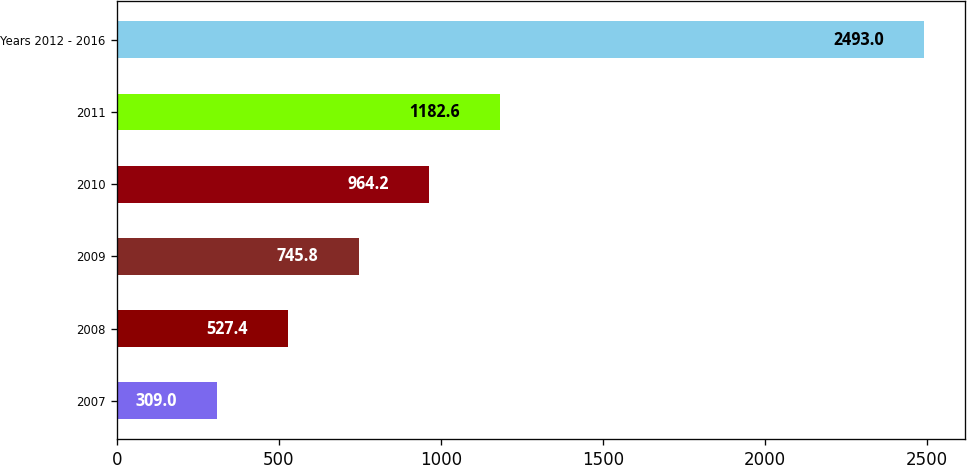<chart> <loc_0><loc_0><loc_500><loc_500><bar_chart><fcel>2007<fcel>2008<fcel>2009<fcel>2010<fcel>2011<fcel>Years 2012 - 2016<nl><fcel>309<fcel>527.4<fcel>745.8<fcel>964.2<fcel>1182.6<fcel>2493<nl></chart> 